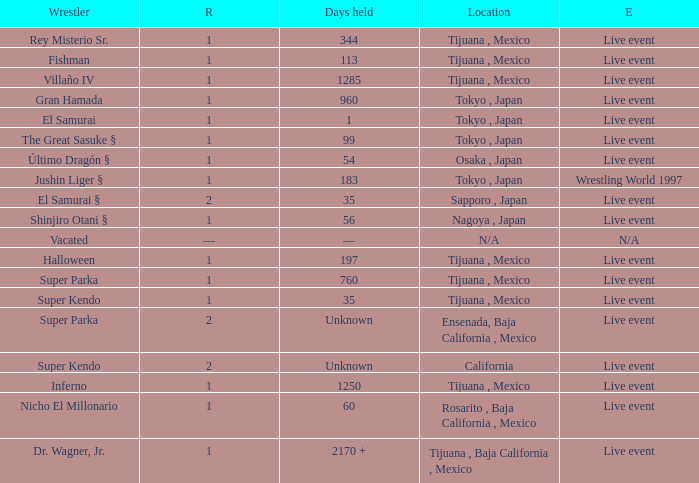What type of event had the wrestler with a reign of 2 and held the title for 35 days? Live event. 